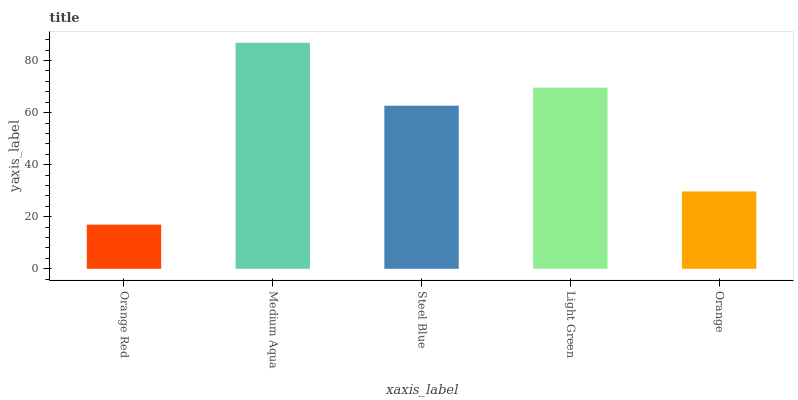Is Orange Red the minimum?
Answer yes or no. Yes. Is Medium Aqua the maximum?
Answer yes or no. Yes. Is Steel Blue the minimum?
Answer yes or no. No. Is Steel Blue the maximum?
Answer yes or no. No. Is Medium Aqua greater than Steel Blue?
Answer yes or no. Yes. Is Steel Blue less than Medium Aqua?
Answer yes or no. Yes. Is Steel Blue greater than Medium Aqua?
Answer yes or no. No. Is Medium Aqua less than Steel Blue?
Answer yes or no. No. Is Steel Blue the high median?
Answer yes or no. Yes. Is Steel Blue the low median?
Answer yes or no. Yes. Is Light Green the high median?
Answer yes or no. No. Is Orange Red the low median?
Answer yes or no. No. 